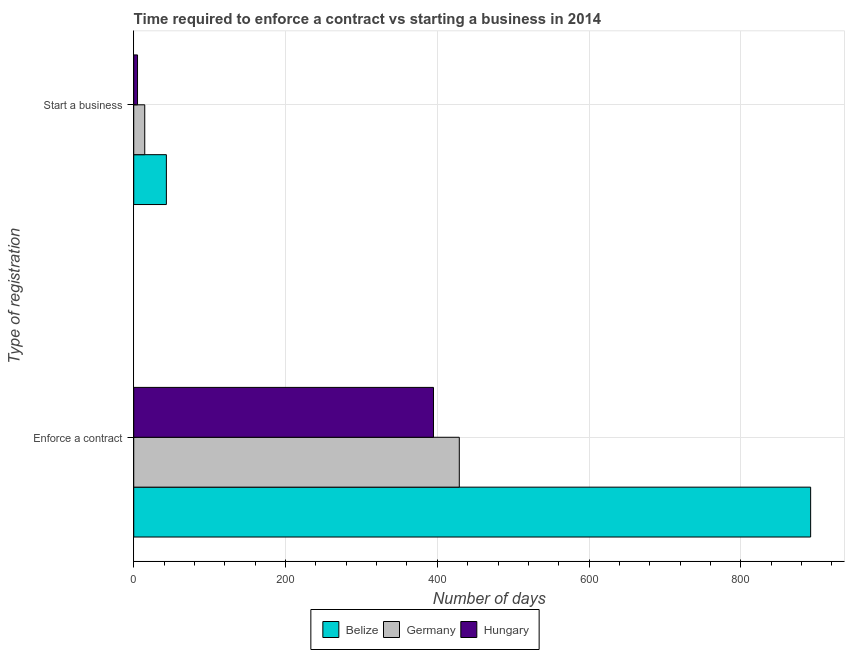How many different coloured bars are there?
Provide a succinct answer. 3. How many groups of bars are there?
Make the answer very short. 2. Are the number of bars per tick equal to the number of legend labels?
Provide a succinct answer. Yes. How many bars are there on the 1st tick from the top?
Your answer should be very brief. 3. How many bars are there on the 2nd tick from the bottom?
Your answer should be compact. 3. What is the label of the 1st group of bars from the top?
Provide a short and direct response. Start a business. What is the number of days to enforece a contract in Germany?
Your answer should be very brief. 429. Across all countries, what is the maximum number of days to enforece a contract?
Provide a succinct answer. 892. Across all countries, what is the minimum number of days to enforece a contract?
Your response must be concise. 395. In which country was the number of days to start a business maximum?
Offer a terse response. Belize. In which country was the number of days to start a business minimum?
Your answer should be compact. Hungary. What is the total number of days to start a business in the graph?
Offer a terse response. 62.5. What is the difference between the number of days to start a business in Hungary and that in Belize?
Give a very brief answer. -38. What is the difference between the number of days to enforece a contract in Belize and the number of days to start a business in Germany?
Provide a short and direct response. 877.5. What is the average number of days to enforece a contract per country?
Make the answer very short. 572. What is the difference between the number of days to enforece a contract and number of days to start a business in Hungary?
Offer a terse response. 390. What is the ratio of the number of days to start a business in Belize to that in Germany?
Your answer should be very brief. 2.97. Is the number of days to start a business in Hungary less than that in Germany?
Provide a short and direct response. Yes. What does the 1st bar from the top in Start a business represents?
Your response must be concise. Hungary. Are all the bars in the graph horizontal?
Your answer should be compact. Yes. What is the difference between two consecutive major ticks on the X-axis?
Ensure brevity in your answer.  200. Does the graph contain any zero values?
Provide a short and direct response. No. Does the graph contain grids?
Your response must be concise. Yes. Where does the legend appear in the graph?
Offer a very short reply. Bottom center. What is the title of the graph?
Provide a succinct answer. Time required to enforce a contract vs starting a business in 2014. What is the label or title of the X-axis?
Give a very brief answer. Number of days. What is the label or title of the Y-axis?
Provide a succinct answer. Type of registration. What is the Number of days of Belize in Enforce a contract?
Your answer should be compact. 892. What is the Number of days in Germany in Enforce a contract?
Your answer should be very brief. 429. What is the Number of days in Hungary in Enforce a contract?
Offer a very short reply. 395. What is the Number of days in Hungary in Start a business?
Your response must be concise. 5. Across all Type of registration, what is the maximum Number of days in Belize?
Offer a terse response. 892. Across all Type of registration, what is the maximum Number of days of Germany?
Keep it short and to the point. 429. Across all Type of registration, what is the maximum Number of days of Hungary?
Your response must be concise. 395. Across all Type of registration, what is the minimum Number of days of Belize?
Offer a terse response. 43. What is the total Number of days of Belize in the graph?
Make the answer very short. 935. What is the total Number of days of Germany in the graph?
Provide a short and direct response. 443.5. What is the difference between the Number of days in Belize in Enforce a contract and that in Start a business?
Offer a terse response. 849. What is the difference between the Number of days in Germany in Enforce a contract and that in Start a business?
Your response must be concise. 414.5. What is the difference between the Number of days of Hungary in Enforce a contract and that in Start a business?
Your answer should be compact. 390. What is the difference between the Number of days in Belize in Enforce a contract and the Number of days in Germany in Start a business?
Keep it short and to the point. 877.5. What is the difference between the Number of days of Belize in Enforce a contract and the Number of days of Hungary in Start a business?
Offer a very short reply. 887. What is the difference between the Number of days of Germany in Enforce a contract and the Number of days of Hungary in Start a business?
Provide a short and direct response. 424. What is the average Number of days of Belize per Type of registration?
Offer a very short reply. 467.5. What is the average Number of days of Germany per Type of registration?
Provide a short and direct response. 221.75. What is the average Number of days of Hungary per Type of registration?
Make the answer very short. 200. What is the difference between the Number of days in Belize and Number of days in Germany in Enforce a contract?
Your answer should be very brief. 463. What is the difference between the Number of days in Belize and Number of days in Hungary in Enforce a contract?
Give a very brief answer. 497. What is the difference between the Number of days in Germany and Number of days in Hungary in Enforce a contract?
Provide a short and direct response. 34. What is the difference between the Number of days of Belize and Number of days of Germany in Start a business?
Provide a short and direct response. 28.5. What is the difference between the Number of days of Belize and Number of days of Hungary in Start a business?
Make the answer very short. 38. What is the ratio of the Number of days of Belize in Enforce a contract to that in Start a business?
Provide a succinct answer. 20.74. What is the ratio of the Number of days of Germany in Enforce a contract to that in Start a business?
Give a very brief answer. 29.59. What is the ratio of the Number of days in Hungary in Enforce a contract to that in Start a business?
Keep it short and to the point. 79. What is the difference between the highest and the second highest Number of days of Belize?
Offer a very short reply. 849. What is the difference between the highest and the second highest Number of days in Germany?
Provide a succinct answer. 414.5. What is the difference between the highest and the second highest Number of days of Hungary?
Offer a very short reply. 390. What is the difference between the highest and the lowest Number of days in Belize?
Ensure brevity in your answer.  849. What is the difference between the highest and the lowest Number of days of Germany?
Give a very brief answer. 414.5. What is the difference between the highest and the lowest Number of days of Hungary?
Offer a very short reply. 390. 